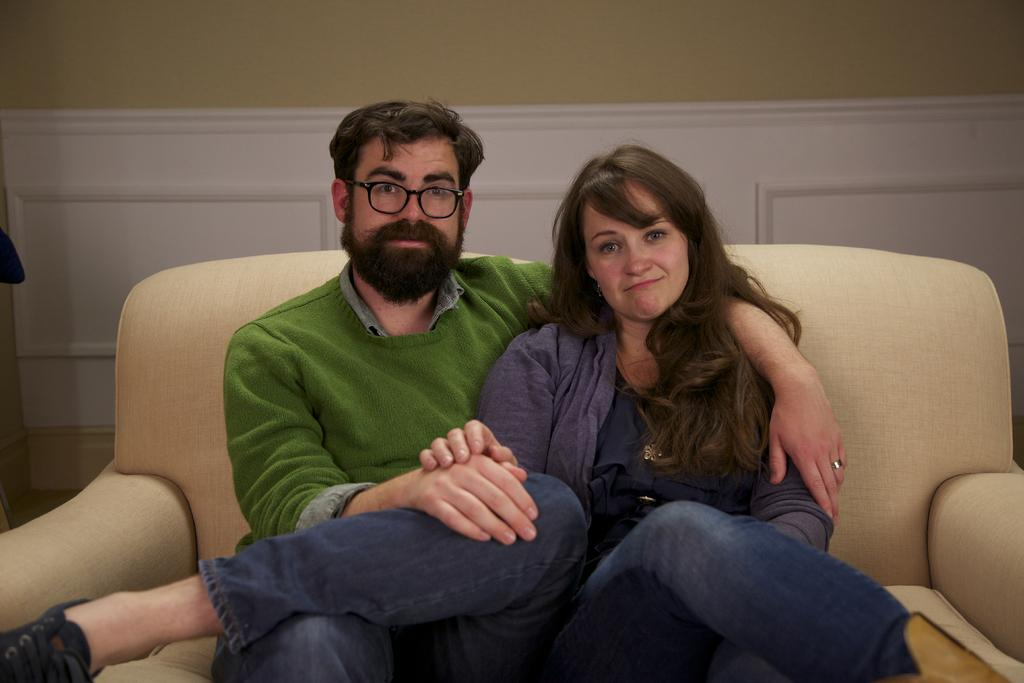How many people are in the image? There are two people in the image, a man and a woman. What are the man and woman doing in the image? The man and woman are sitting on a sofa. What is the man wearing in the image? The man is wearing a green sweater and blue jeans. What is the woman wearing in the image? The woman is wearing a purple sweater. What can be seen in the background of the image? There is a wall in the background of the image. What type of wilderness can be seen in the background of the image? There is no wilderness visible in the background of the image; it features a wall. Can you tell me how many dinosaurs are present in the image? There are no dinosaurs present in the image; it features a man and a woman sitting on a sofa. 